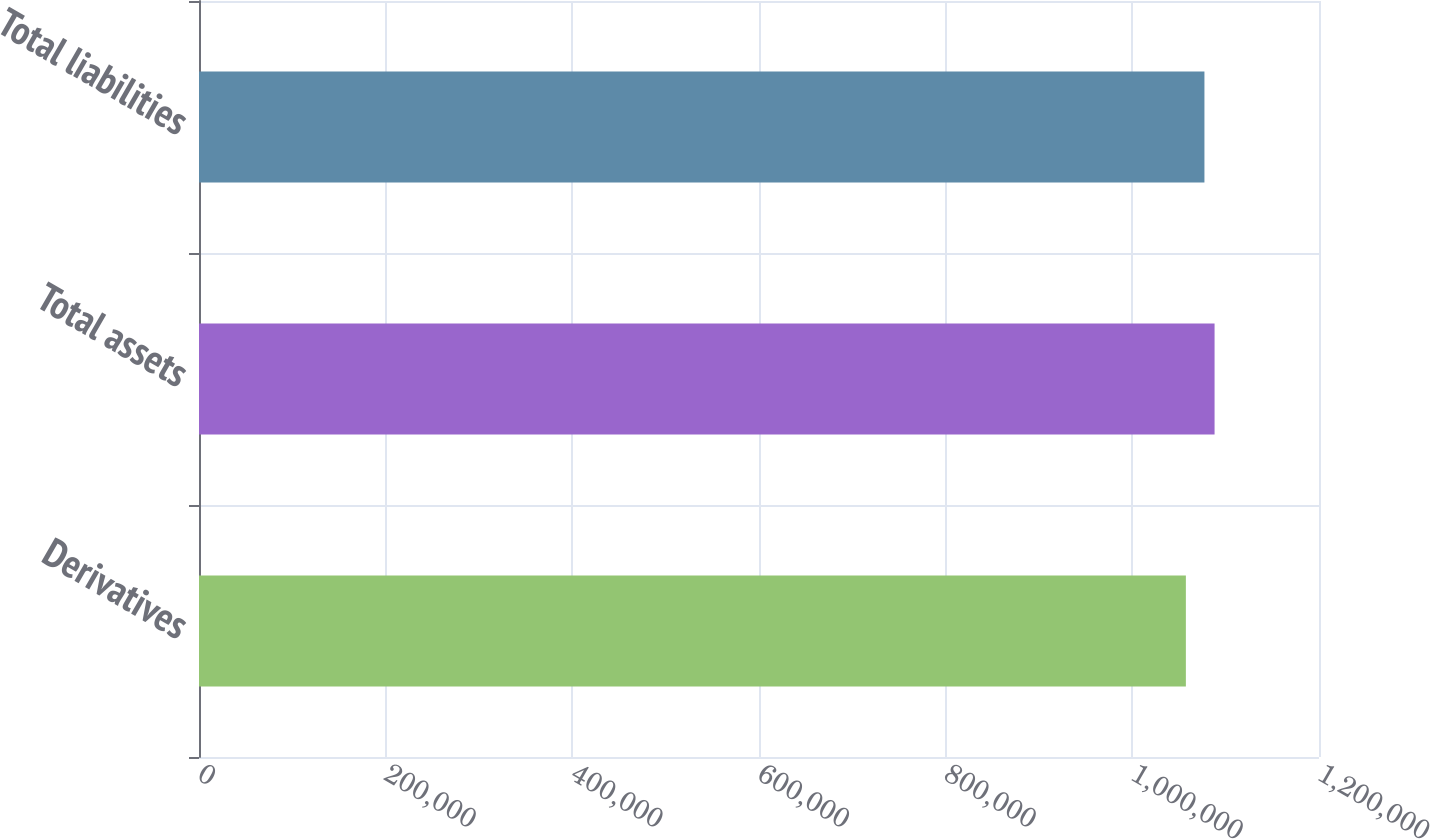Convert chart. <chart><loc_0><loc_0><loc_500><loc_500><bar_chart><fcel>Derivatives<fcel>Total assets<fcel>Total liabilities<nl><fcel>1.05736e+06<fcel>1.08811e+06<fcel>1.07725e+06<nl></chart> 